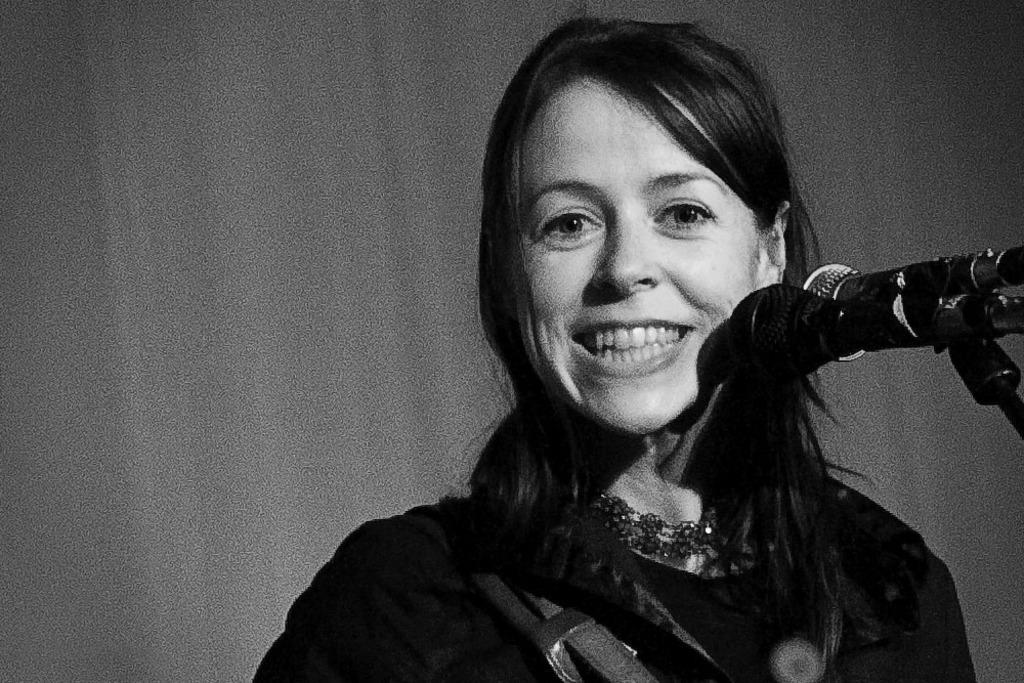What is the color scheme of the image? The image is black and white. Who is present in the image? There is a woman in the image. What is the woman doing in the image? The woman is smiling. What object can be seen in the image that is typically used for amplifying sound? There is a microphone (mic) in the image. What type of linen is being used to clean the microphone in the image? There is no linen or cleaning activity involving the microphone present in the image. 